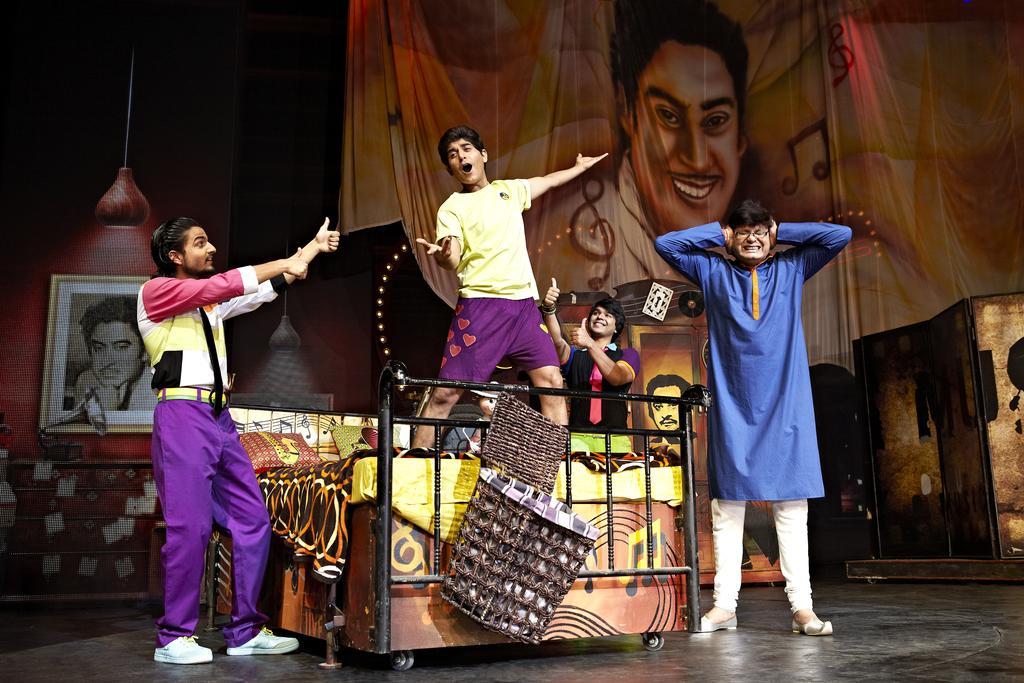Can you describe this image briefly? As we can see in the image there is banner, few people, photo frame, light, mats and bed. 